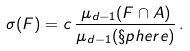<formula> <loc_0><loc_0><loc_500><loc_500>\sigma ( F ) = c \, \frac { \mu _ { d - 1 } ( F \cap A ) } { \mu _ { d - 1 } ( \S p h e r e ) } \, .</formula> 